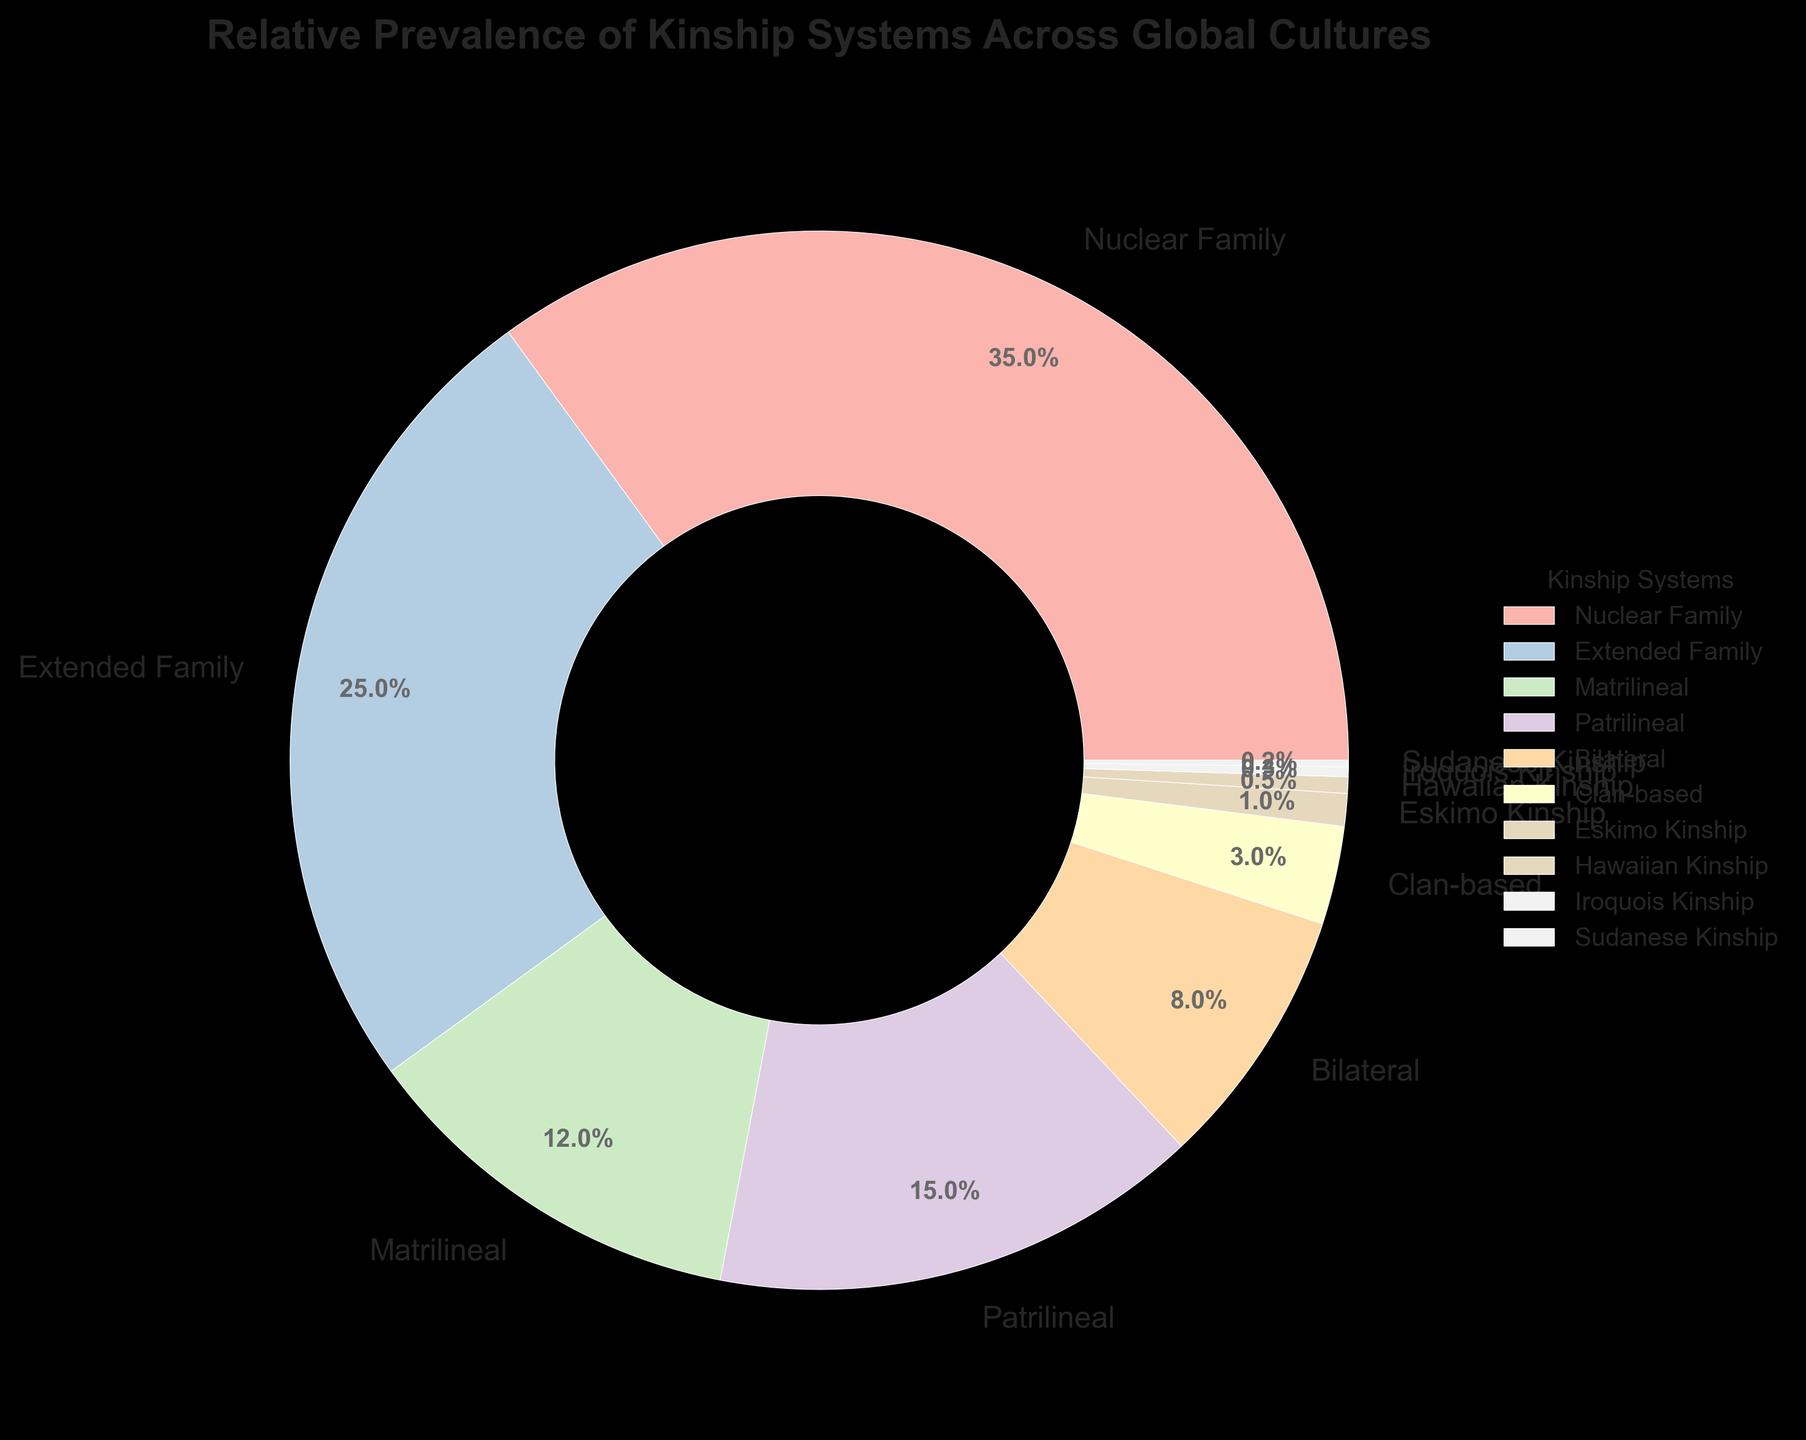What is the most common kinship system according to the figure? The figure shows that the largest portion of the pie chart, labeled with the percentage 35%, represents the Nuclear Family. This indicates that the Nuclear Family is the most common kinship system.
Answer: Nuclear Family Which kinship system is less prevalent: Matrilineal or Patrilineal? The pie chart shows that the Matrilineal system has a percentage of 12%, while the Patrilineal system has a percentage of 15%. Therefore, the Matrilineal system is less prevalent.
Answer: Matrilineal Among the kinship systems shown, identify those contributing less than 1% each to the total. From the pie chart, the four smallest slices, each contributing less than 1%, are: Eskimo Kinship (1%), Hawaiian Kinship (0.5%), Iroquois Kinship (0.3%), and Sudanese Kinship (0.2%).
Answer: Eskimo Kinship, Hawaiian Kinship, Iroquois Kinship, Sudanese Kinship What is the combined percentage of Extended Family and Bilateral systems? According to the figure, the Extended Family system has 25% and the Bilateral system has 8%. Adding these percentages gives 25% + 8% = 33%.
Answer: 33% Which kinship system has the smallest visual representation? The smallest slice of the pie chart represents the Sudanese Kinship system, which has a percentage of 0.2%.
Answer: Sudanese Kinship Compare the percentages of Clan-based and Bilateral kinship systems. Which is higher and by how much? The pie chart shows that the Clan-based system is at 3%, while the Bilateral system is at 8%. The Bilateral system is higher by 8% - 3% = 5%.
Answer: Bilateral is higher by 5% What is the total percentage covered by Matrilineal, Patrilineal, and Clan-based systems combined? According to the pie chart, Matrilineal is 12%, Patrilineal is 15%, and Clan-based is 3%. Adding these percentages gives 12% + 15% + 3% = 30%.
Answer: 30% If the Extended Family and Nuclear Family systems are combined into a single category, what would their combined percentage be? The figure shows that the Nuclear Family system is 35% and the Extended Family system is 25%. Their combined percentage is 35% + 25% = 60%.
Answer: 60% Which kinship systems have percentages within 1 percentage point of each other? By examining the pie chart, the percentages of Matrilineal (12%) and Patrilineal (15%) are within 1 percentage point of the Bilateral system (8%). Specifically, Matrilineal and Patrilineal are within 3 percentage points of each other.
Answer: Matrilineal and Patrilineal 